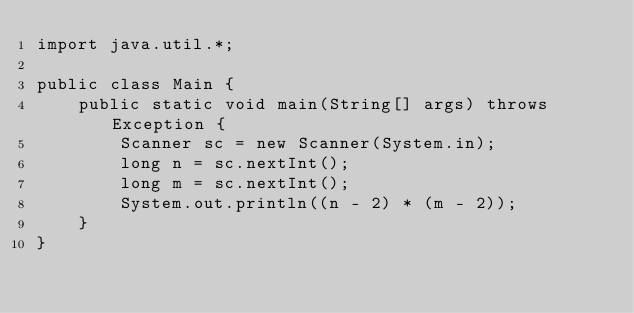<code> <loc_0><loc_0><loc_500><loc_500><_Java_>import java.util.*;

public class Main {
    public static void main(String[] args) throws Exception {
        Scanner sc = new Scanner(System.in);
        long n = sc.nextInt();
        long m = sc.nextInt();
        System.out.println((n - 2) * (m - 2));
    }
}
</code> 